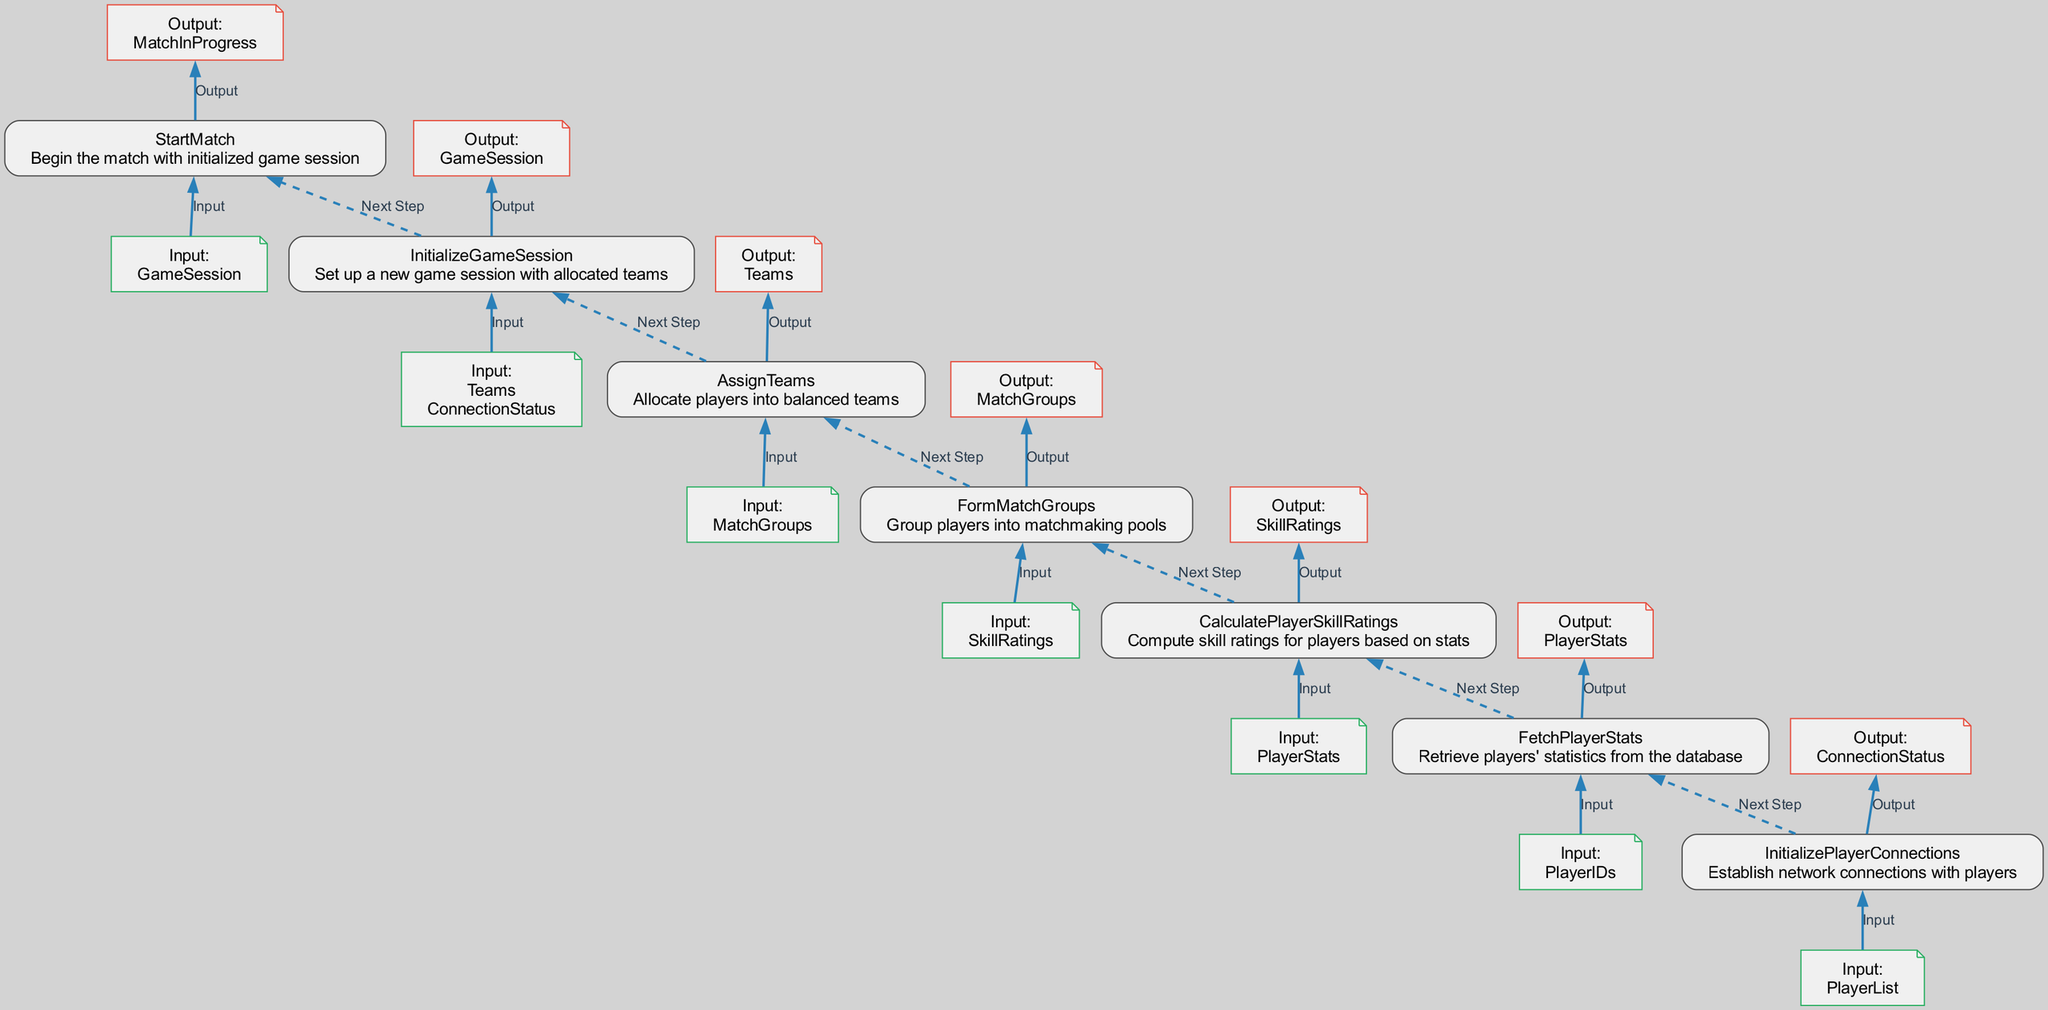What is the first node in the flow? The first node in the flow is identified as "InitializePlayerConnections", which is the starting point of the matchmaking process.
Answer: InitializePlayerConnections How many nodes are there in the diagram? By counting each distinct function node in the diagram, we find there are seven nodes representing different processes in the matchmaking flow.
Answer: 7 What is the output of the "AssignTeams" node? The output of the "AssignTeams" node is "Teams", which indicates the result of player allocation into balanced teams.
Answer: Teams What is the input for the "FetchPlayerStats" node? The input for the "FetchPlayerStats" node is "PlayerIDs", needed to retrieve specific players' statistics from the database.
Answer: PlayerIDs Which node follows "CalculatePlayerSkillRatings"? The node that follows "CalculatePlayerSkillRatings" is "FormMatchGroups", indicating the next step in processing after skill ratings have been calculated.
Answer: FormMatchGroups What is the relationship between "InitializeGameSession" and "AssignTeams"? "InitializeGameSession" takes its input from "Teams", which are outputted by "AssignTeams", illustrating that team assignment is essential for setting up a game session.
Answer: Teams Which node has the input "MatchGroups"? The node with the input "MatchGroups" is "AssignTeams", making it clear that the team allocation process relies on the match groupings.
Answer: AssignTeams What is the last node in the flow? The last node in the flow is "StartMatch", indicating the final action taken to begin the match after everything has been set up.
Answer: StartMatch What color is used for the output notes? The output notes are colored in red, distinctively marking them from input notes, which are green.
Answer: Red 